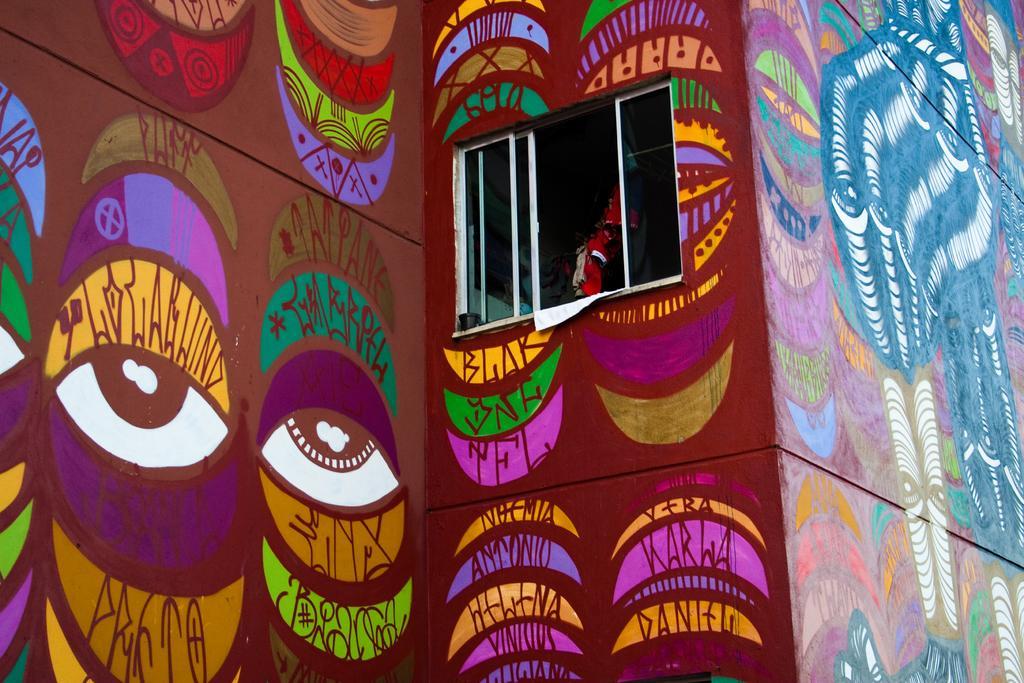Please provide a concise description of this image. In this image, we can see an art on the wall. There is a window in the middle of the image. 